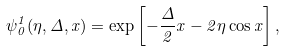<formula> <loc_0><loc_0><loc_500><loc_500>\psi _ { 0 } ^ { 1 } ( \eta , \Delta , x ) = \exp \left [ - \frac { \Delta } { 2 } x - 2 \eta \cos x \right ] ,</formula> 